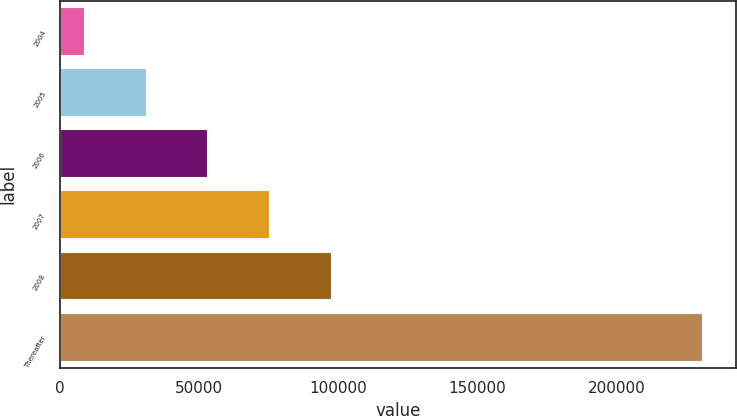<chart> <loc_0><loc_0><loc_500><loc_500><bar_chart><fcel>2004<fcel>2005<fcel>2006<fcel>2007<fcel>2008<fcel>Thereafter<nl><fcel>8885<fcel>31116.7<fcel>53348.4<fcel>75580.1<fcel>97811.8<fcel>231202<nl></chart> 